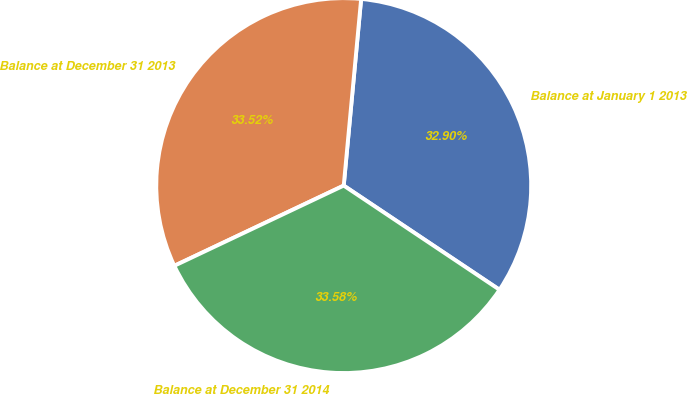Convert chart to OTSL. <chart><loc_0><loc_0><loc_500><loc_500><pie_chart><fcel>Balance at January 1 2013<fcel>Balance at December 31 2013<fcel>Balance at December 31 2014<nl><fcel>32.9%<fcel>33.52%<fcel>33.58%<nl></chart> 